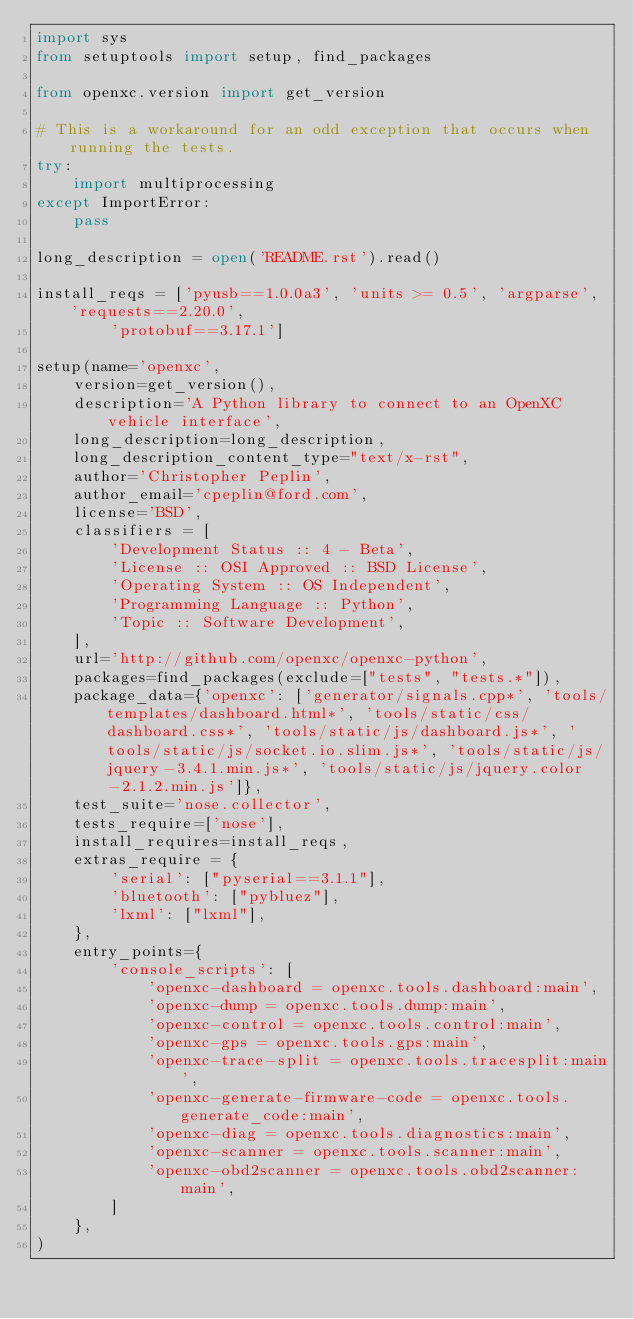Convert code to text. <code><loc_0><loc_0><loc_500><loc_500><_Python_>import sys
from setuptools import setup, find_packages

from openxc.version import get_version

# This is a workaround for an odd exception that occurs when running the tests.
try:
    import multiprocessing
except ImportError:
    pass

long_description = open('README.rst').read()

install_reqs = ['pyusb==1.0.0a3', 'units >= 0.5', 'argparse', 'requests==2.20.0',
        'protobuf==3.17.1']

setup(name='openxc',
    version=get_version(),
    description='A Python library to connect to an OpenXC vehicle interface',
    long_description=long_description,
	long_description_content_type="text/x-rst",
    author='Christopher Peplin',
    author_email='cpeplin@ford.com',
    license='BSD',
    classifiers = [
        'Development Status :: 4 - Beta',
        'License :: OSI Approved :: BSD License',
        'Operating System :: OS Independent',
        'Programming Language :: Python',
        'Topic :: Software Development',
    ],
    url='http://github.com/openxc/openxc-python',
    packages=find_packages(exclude=["tests", "tests.*"]),
    package_data={'openxc': ['generator/signals.cpp*', 'tools/templates/dashboard.html*', 'tools/static/css/dashboard.css*', 'tools/static/js/dashboard.js*', 'tools/static/js/socket.io.slim.js*', 'tools/static/js/jquery-3.4.1.min.js*', 'tools/static/js/jquery.color-2.1.2.min.js']},
    test_suite='nose.collector',
    tests_require=['nose'],
    install_requires=install_reqs,
    extras_require = {
        'serial': ["pyserial==3.1.1"],
        'bluetooth': ["pybluez"],
        'lxml': ["lxml"],
    },
    entry_points={
        'console_scripts': [
            'openxc-dashboard = openxc.tools.dashboard:main',
            'openxc-dump = openxc.tools.dump:main',
            'openxc-control = openxc.tools.control:main',
            'openxc-gps = openxc.tools.gps:main',
            'openxc-trace-split = openxc.tools.tracesplit:main',
            'openxc-generate-firmware-code = openxc.tools.generate_code:main',
            'openxc-diag = openxc.tools.diagnostics:main',
            'openxc-scanner = openxc.tools.scanner:main',
            'openxc-obd2scanner = openxc.tools.obd2scanner:main',
        ]
    },
)
</code> 